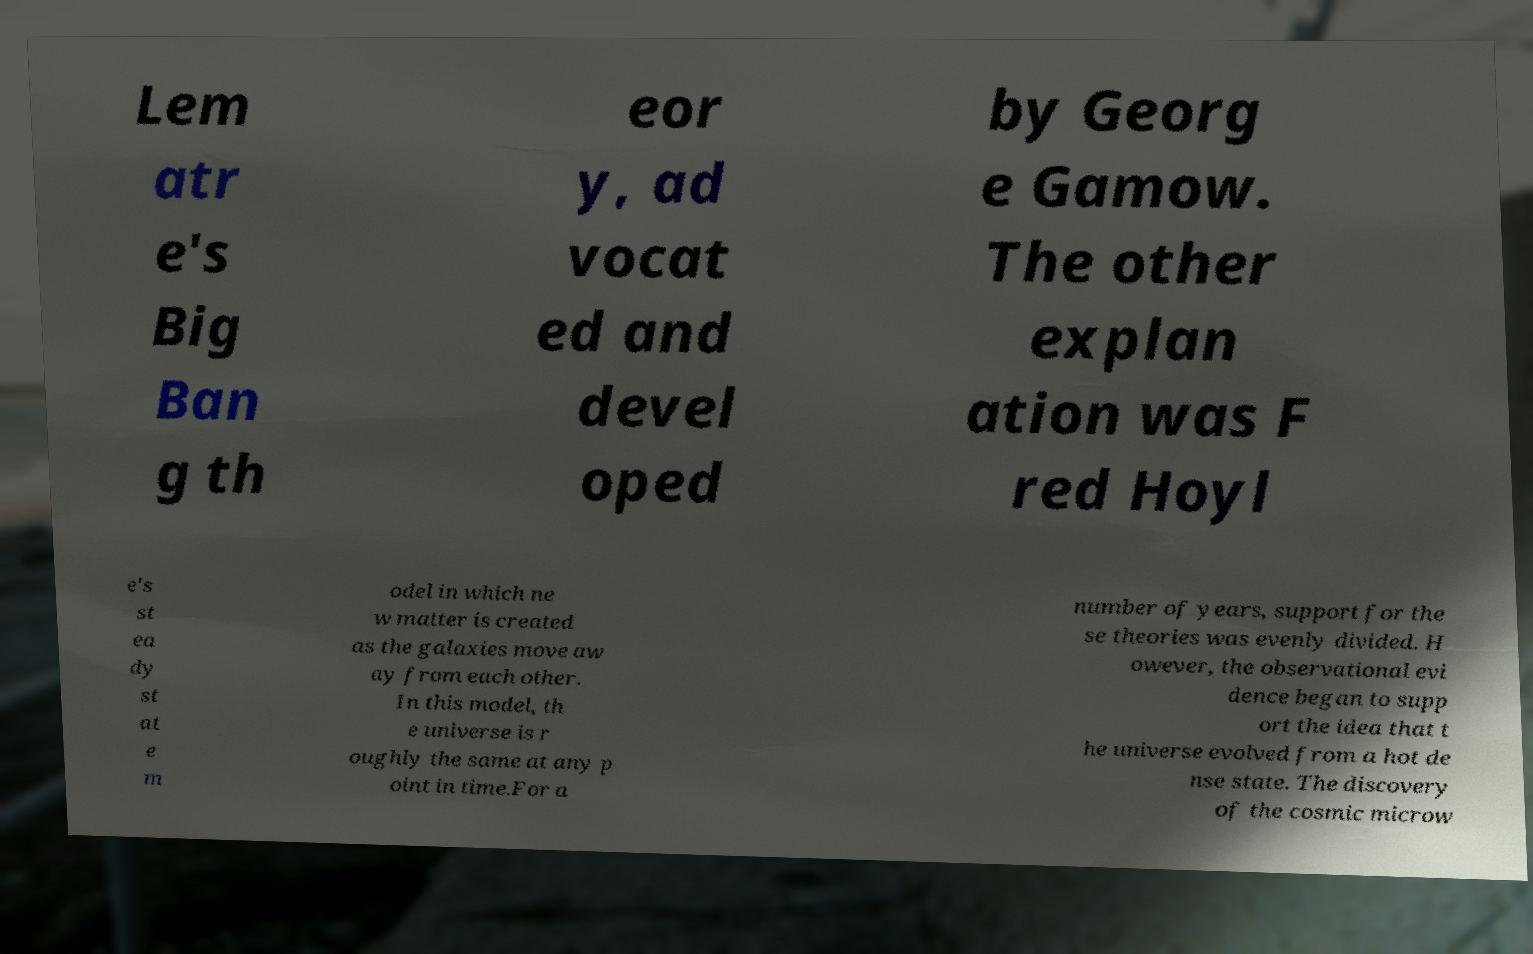Could you assist in decoding the text presented in this image and type it out clearly? Lem atr e's Big Ban g th eor y, ad vocat ed and devel oped by Georg e Gamow. The other explan ation was F red Hoyl e's st ea dy st at e m odel in which ne w matter is created as the galaxies move aw ay from each other. In this model, th e universe is r oughly the same at any p oint in time.For a number of years, support for the se theories was evenly divided. H owever, the observational evi dence began to supp ort the idea that t he universe evolved from a hot de nse state. The discovery of the cosmic microw 